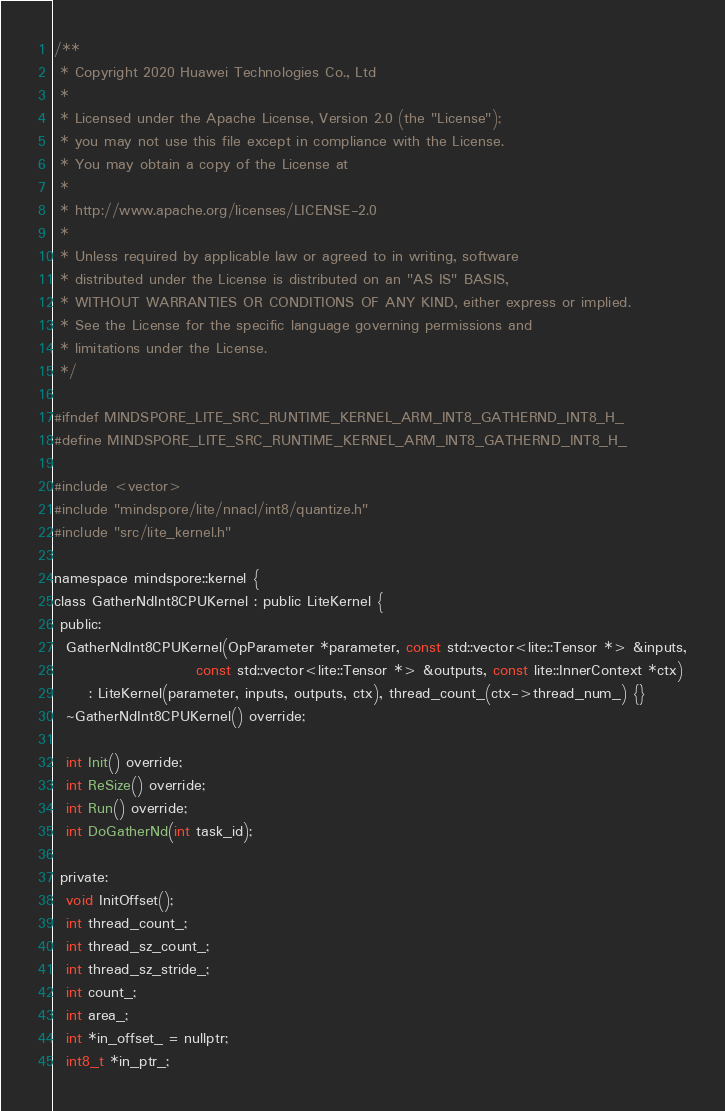Convert code to text. <code><loc_0><loc_0><loc_500><loc_500><_C_>/**
 * Copyright 2020 Huawei Technologies Co., Ltd
 *
 * Licensed under the Apache License, Version 2.0 (the "License");
 * you may not use this file except in compliance with the License.
 * You may obtain a copy of the License at
 *
 * http://www.apache.org/licenses/LICENSE-2.0
 *
 * Unless required by applicable law or agreed to in writing, software
 * distributed under the License is distributed on an "AS IS" BASIS,
 * WITHOUT WARRANTIES OR CONDITIONS OF ANY KIND, either express or implied.
 * See the License for the specific language governing permissions and
 * limitations under the License.
 */

#ifndef MINDSPORE_LITE_SRC_RUNTIME_KERNEL_ARM_INT8_GATHERND_INT8_H_
#define MINDSPORE_LITE_SRC_RUNTIME_KERNEL_ARM_INT8_GATHERND_INT8_H_

#include <vector>
#include "mindspore/lite/nnacl/int8/quantize.h"
#include "src/lite_kernel.h"

namespace mindspore::kernel {
class GatherNdInt8CPUKernel : public LiteKernel {
 public:
  GatherNdInt8CPUKernel(OpParameter *parameter, const std::vector<lite::Tensor *> &inputs,
                        const std::vector<lite::Tensor *> &outputs, const lite::InnerContext *ctx)
      : LiteKernel(parameter, inputs, outputs, ctx), thread_count_(ctx->thread_num_) {}
  ~GatherNdInt8CPUKernel() override;

  int Init() override;
  int ReSize() override;
  int Run() override;
  int DoGatherNd(int task_id);

 private:
  void InitOffset();
  int thread_count_;
  int thread_sz_count_;
  int thread_sz_stride_;
  int count_;
  int area_;
  int *in_offset_ = nullptr;
  int8_t *in_ptr_;</code> 